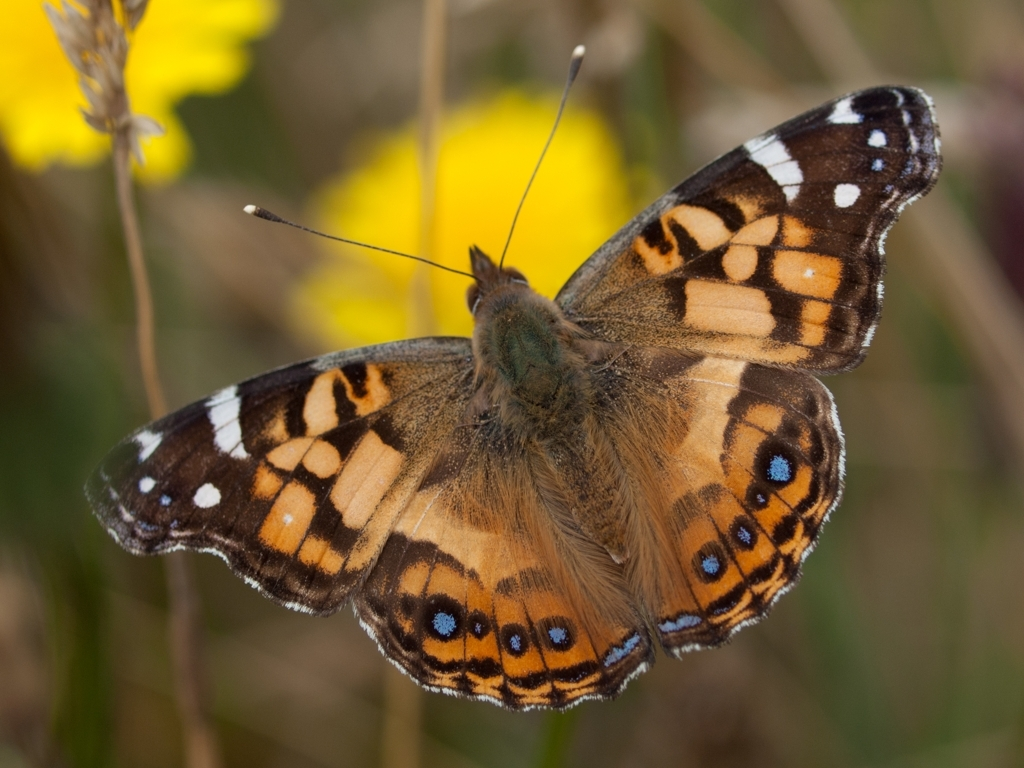What can you tell me about the habitat in which this butterfly was photographed? The butterfly is surrounded by a natural habitat composed of wildflowers and grass. The presence of such flora suggests that this setting could be a meadow or open field – typical habitats for butterflies due to the abundant nectar sources and the availability of host plants for caterpillars. How does the butterfly's appearance help it survive in this habitat? The butterfly’s pattern of bright colors mixed with earth tones can serve as a warning to potential predators that it might be distasteful. Simultaneously, the patterns provide excellent camouflage when the butterfly rests among flowers and foliage, blending in to avoid detection. 